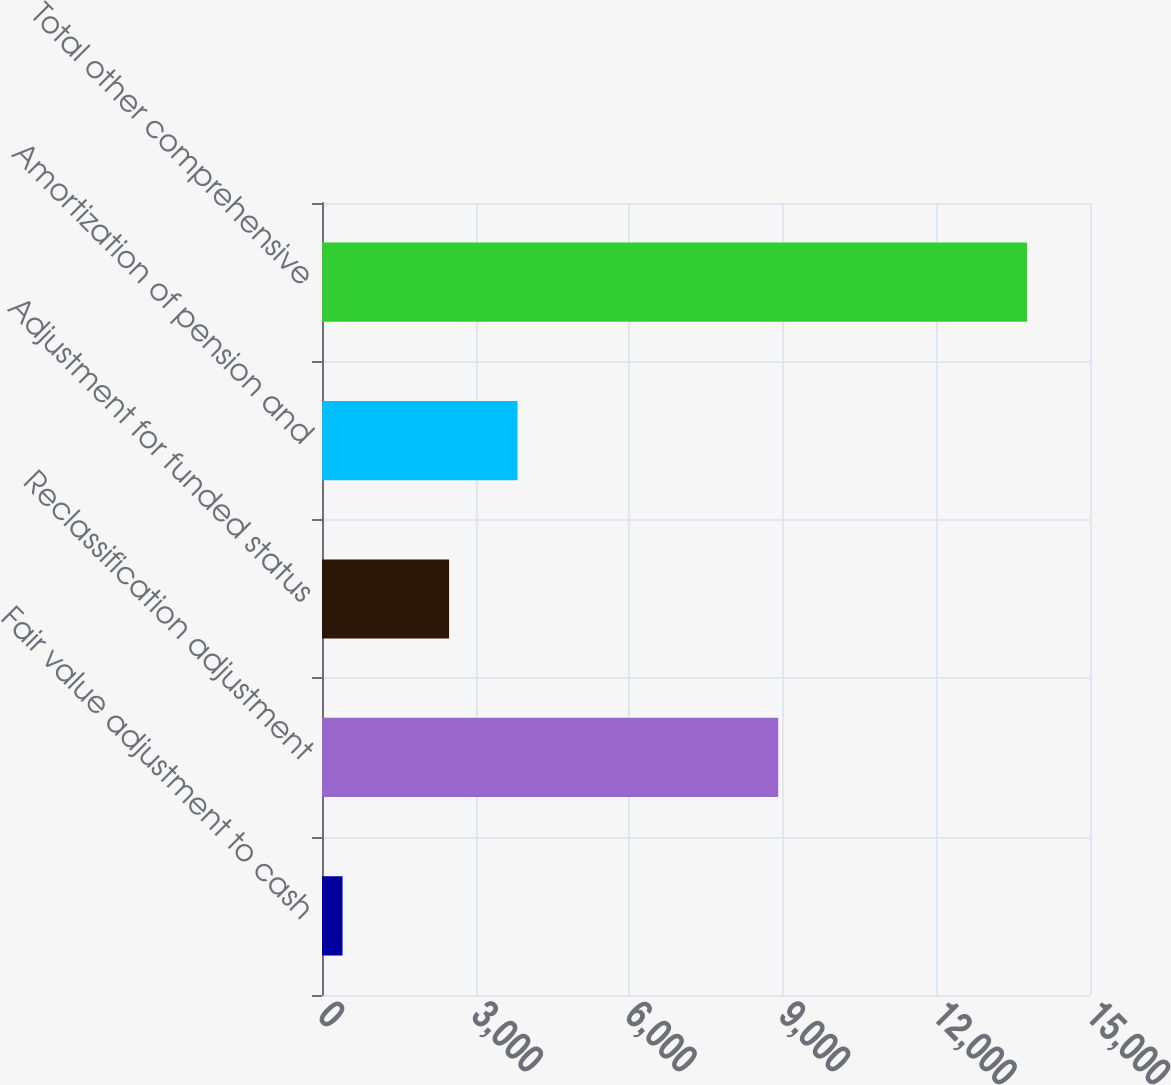Convert chart. <chart><loc_0><loc_0><loc_500><loc_500><bar_chart><fcel>Fair value adjustment to cash<fcel>Reclassification adjustment<fcel>Adjustment for funded status<fcel>Amortization of pension and<fcel>Total other comprehensive<nl><fcel>401<fcel>8910<fcel>2482<fcel>3819.1<fcel>13772<nl></chart> 